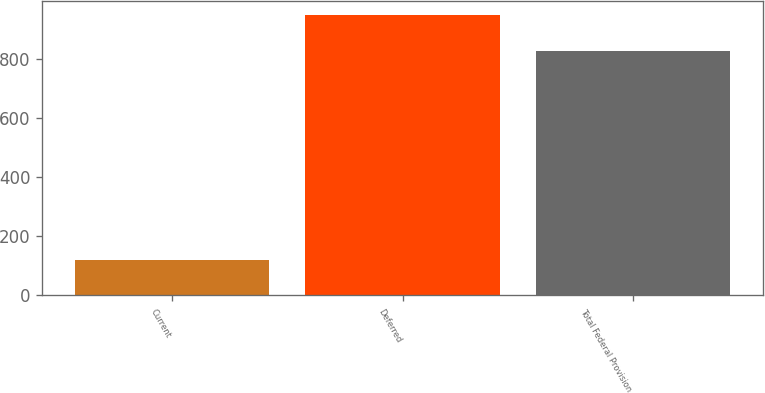<chart> <loc_0><loc_0><loc_500><loc_500><bar_chart><fcel>Current<fcel>Deferred<fcel>Total Federal Provision<nl><fcel>120<fcel>947<fcel>827<nl></chart> 